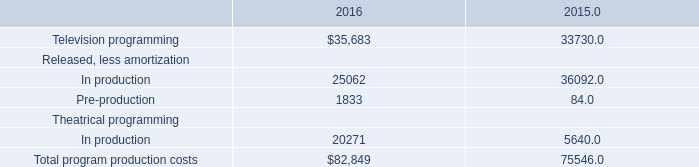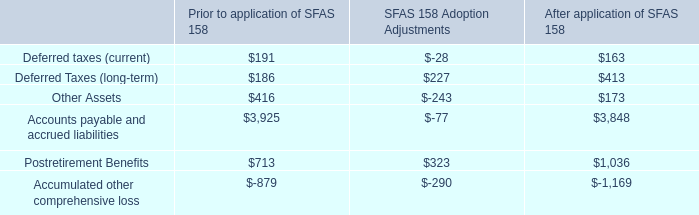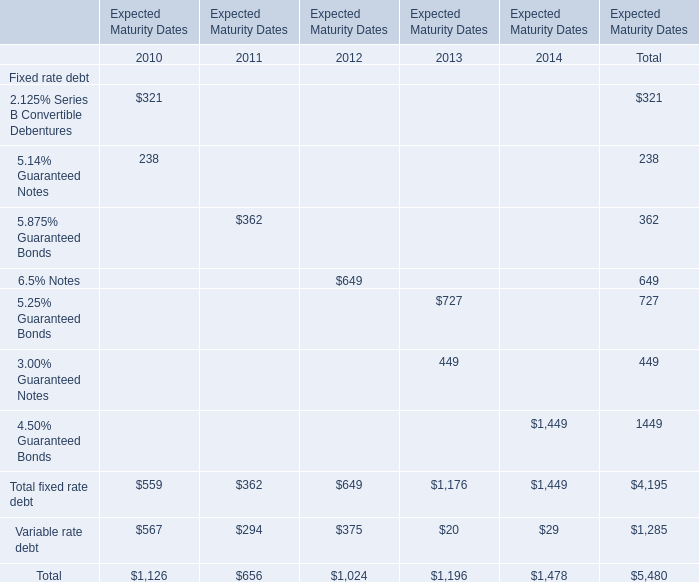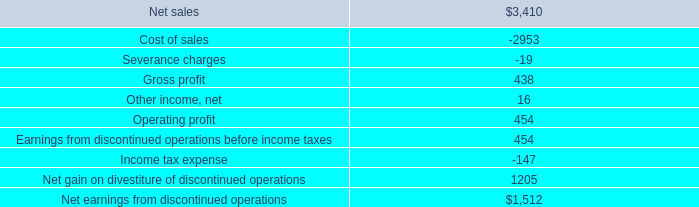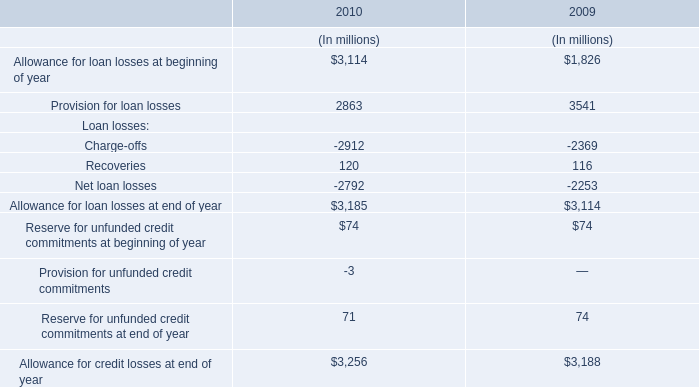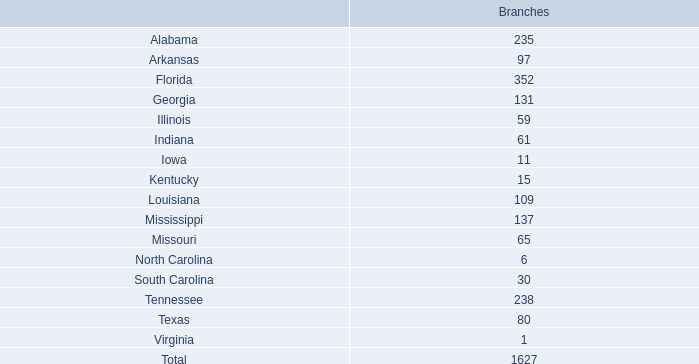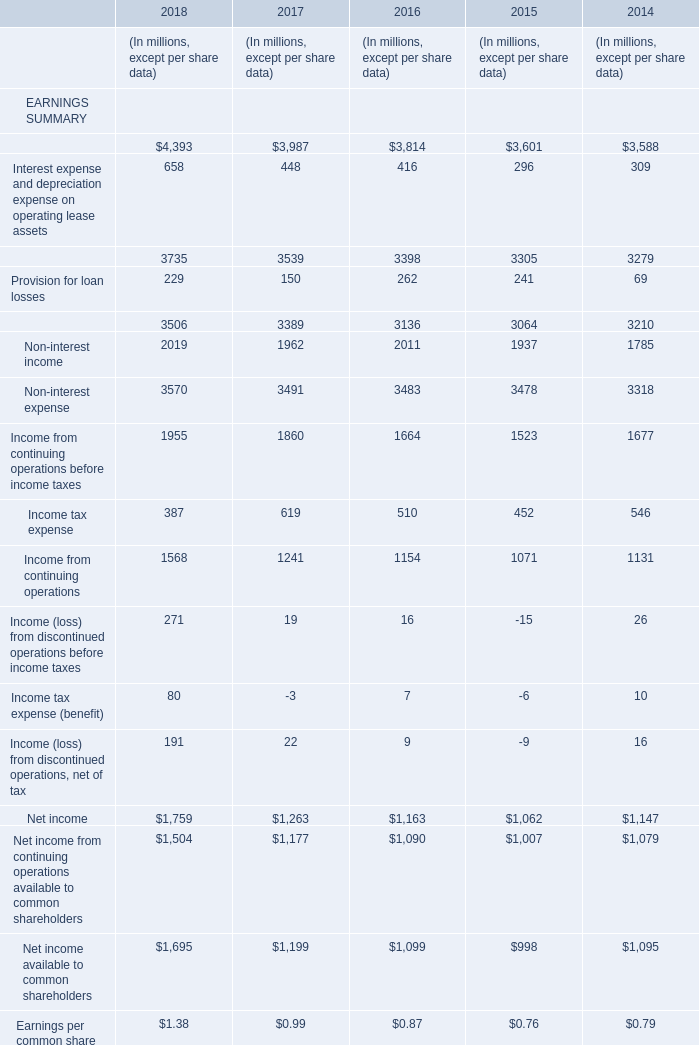What is the value of the Total fixed rate debt for the Expected Maturity Dates 2013? 
Answer: 1176. 